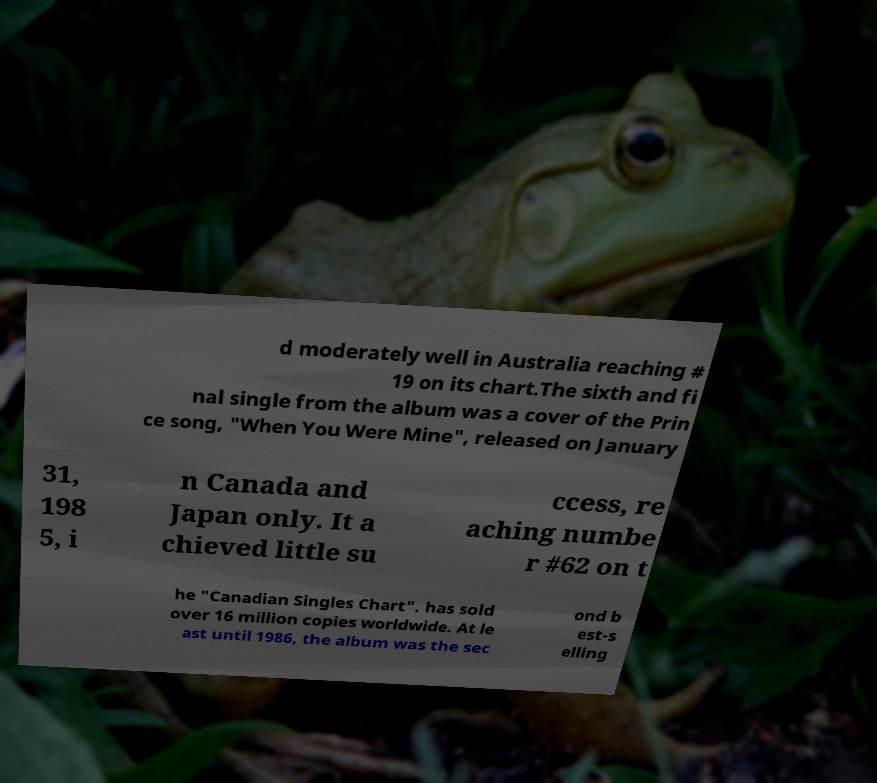I need the written content from this picture converted into text. Can you do that? d moderately well in Australia reaching # 19 on its chart.The sixth and fi nal single from the album was a cover of the Prin ce song, "When You Were Mine", released on January 31, 198 5, i n Canada and Japan only. It a chieved little su ccess, re aching numbe r #62 on t he "Canadian Singles Chart". has sold over 16 million copies worldwide. At le ast until 1986, the album was the sec ond b est-s elling 